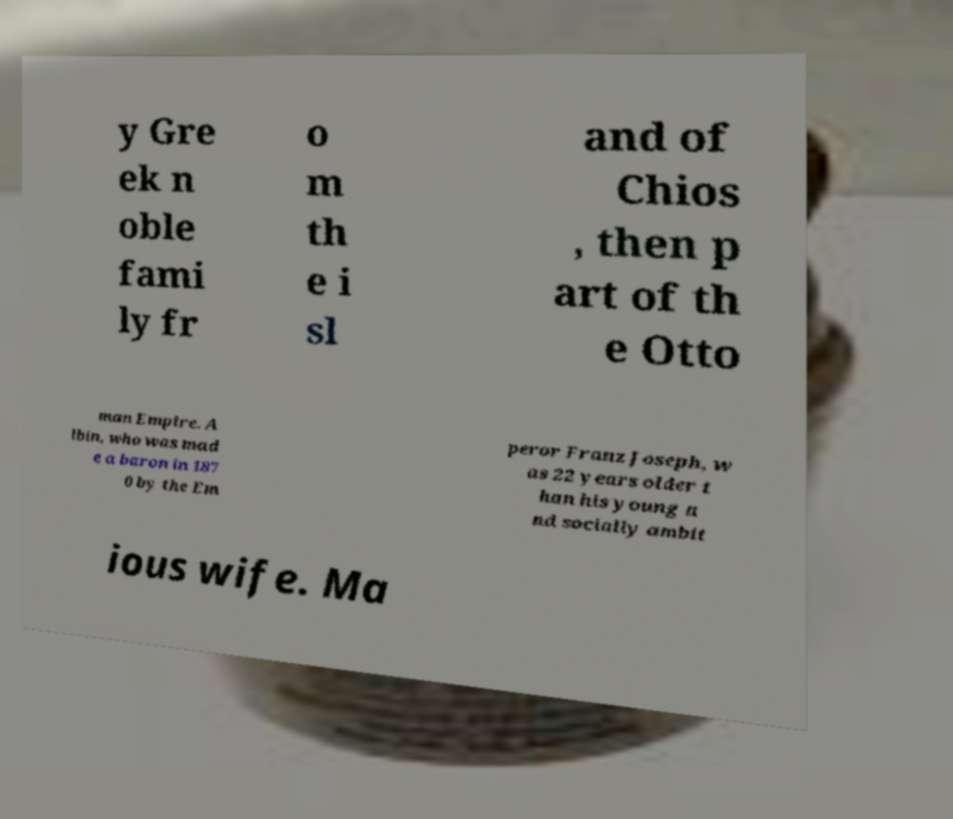I need the written content from this picture converted into text. Can you do that? y Gre ek n oble fami ly fr o m th e i sl and of Chios , then p art of th e Otto man Empire. A lbin, who was mad e a baron in 187 0 by the Em peror Franz Joseph, w as 22 years older t han his young a nd socially ambit ious wife. Ma 